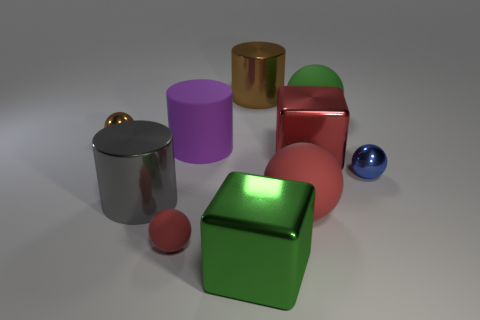Subtract all blue balls. How many balls are left? 4 Subtract all brown balls. How many balls are left? 4 Subtract all gray balls. Subtract all gray cylinders. How many balls are left? 5 Subtract all cubes. How many objects are left? 8 Subtract all big gray spheres. Subtract all large gray shiny cylinders. How many objects are left? 9 Add 3 large objects. How many large objects are left? 10 Add 2 metallic balls. How many metallic balls exist? 4 Subtract 0 cyan cylinders. How many objects are left? 10 